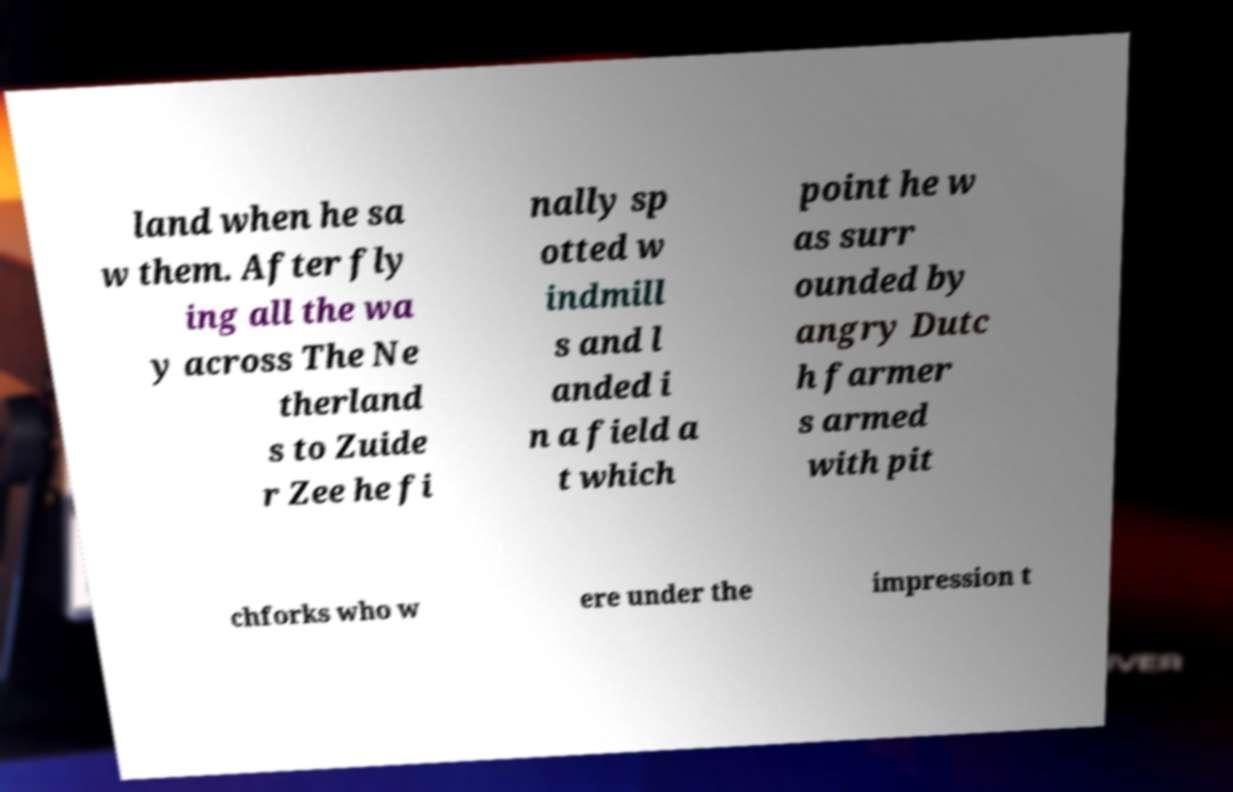Can you accurately transcribe the text from the provided image for me? land when he sa w them. After fly ing all the wa y across The Ne therland s to Zuide r Zee he fi nally sp otted w indmill s and l anded i n a field a t which point he w as surr ounded by angry Dutc h farmer s armed with pit chforks who w ere under the impression t 